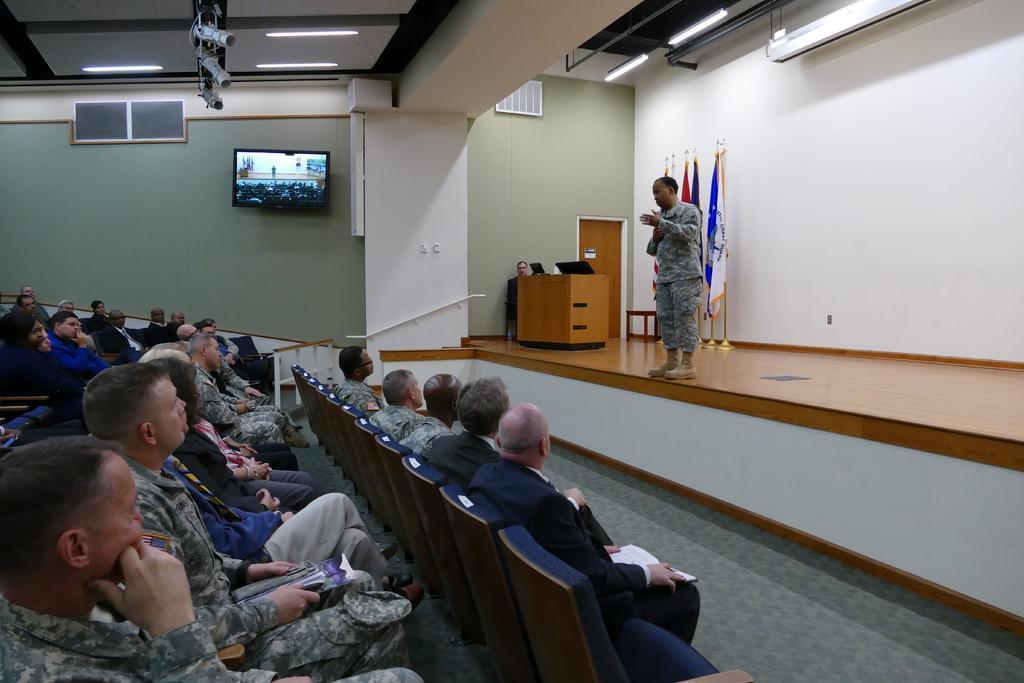Please provide a concise description of this image. These persons are sitting on a chair. On this stage this person is standing. Far there is a table, on a table there are laptops. Beside this wall there are flags. This is door. On top there are lights. A screen on wall. Most of the persons wore military dress. 